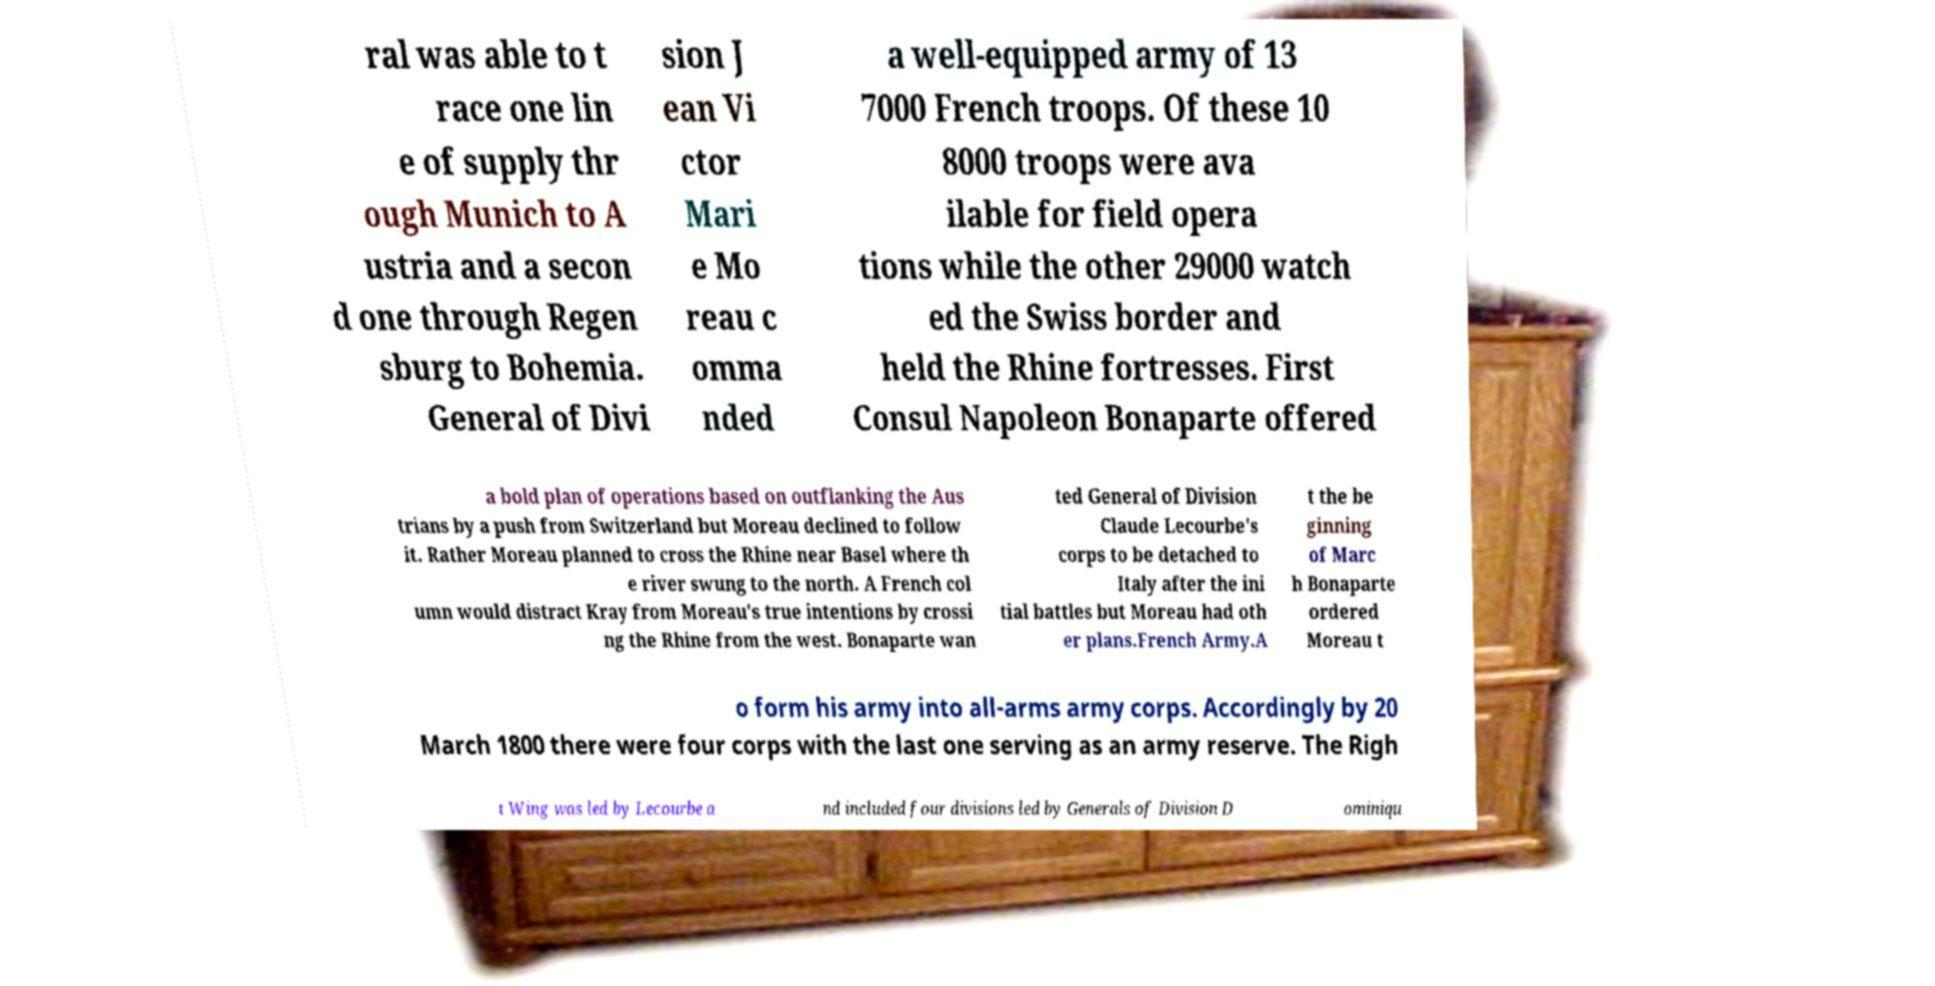Can you read and provide the text displayed in the image?This photo seems to have some interesting text. Can you extract and type it out for me? ral was able to t race one lin e of supply thr ough Munich to A ustria and a secon d one through Regen sburg to Bohemia. General of Divi sion J ean Vi ctor Mari e Mo reau c omma nded a well-equipped army of 13 7000 French troops. Of these 10 8000 troops were ava ilable for field opera tions while the other 29000 watch ed the Swiss border and held the Rhine fortresses. First Consul Napoleon Bonaparte offered a bold plan of operations based on outflanking the Aus trians by a push from Switzerland but Moreau declined to follow it. Rather Moreau planned to cross the Rhine near Basel where th e river swung to the north. A French col umn would distract Kray from Moreau's true intentions by crossi ng the Rhine from the west. Bonaparte wan ted General of Division Claude Lecourbe's corps to be detached to Italy after the ini tial battles but Moreau had oth er plans.French Army.A t the be ginning of Marc h Bonaparte ordered Moreau t o form his army into all-arms army corps. Accordingly by 20 March 1800 there were four corps with the last one serving as an army reserve. The Righ t Wing was led by Lecourbe a nd included four divisions led by Generals of Division D ominiqu 